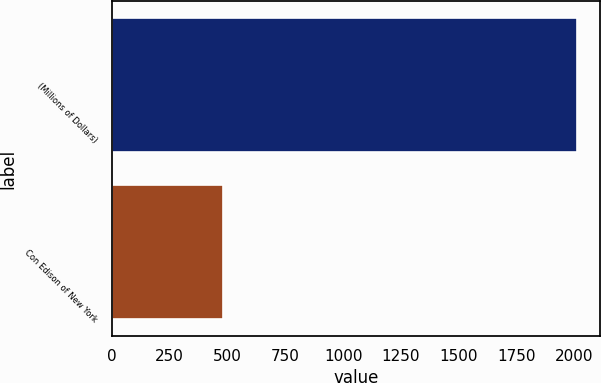<chart> <loc_0><loc_0><loc_500><loc_500><bar_chart><fcel>(Millions of Dollars)<fcel>Con Edison of New York<nl><fcel>2012<fcel>479<nl></chart> 